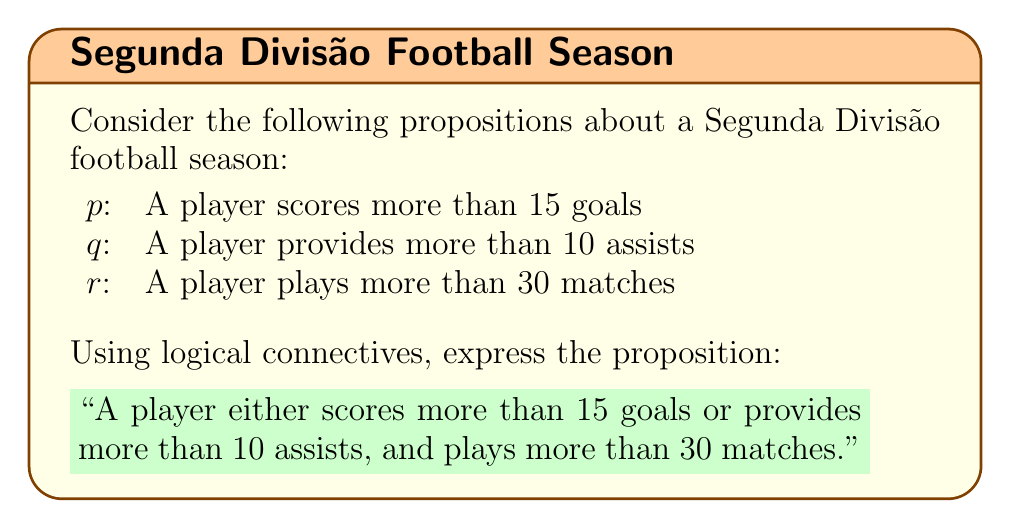Show me your answer to this math problem. To solve this problem, we need to use logical connectives to combine the given propositions into a complex proposition that accurately represents the given statement.

1. First, let's break down the statement:
   - "A player either scores more than 15 goals or provides more than 10 assists"
   - "and plays more than 30 matches"

2. The first part involves an "or" relationship between scoring goals and providing assists. In logical notation, this is represented by the disjunction symbol $\lor$.

3. The second part is connected to the first part with an "and" relationship. In logical notation, this is represented by the conjunction symbol $\land$.

4. Now, let's construct the complex proposition:
   - "scores more than 15 goals or provides more than 10 assists" is represented by $(p \lor q)$
   - "plays more than 30 matches" is represented by $r$
   - Combining these with the "and" relationship gives us: $(p \lor q) \land r$

Therefore, the complete logical expression for the given statement is $(p \lor q) \land r$.
Answer: $(p \lor q) \land r$ 